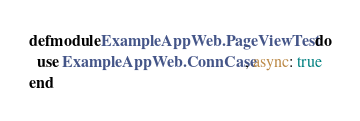Convert code to text. <code><loc_0><loc_0><loc_500><loc_500><_Elixir_>defmodule ExampleAppWeb.PageViewTest do
  use ExampleAppWeb.ConnCase, async: true
end
</code> 